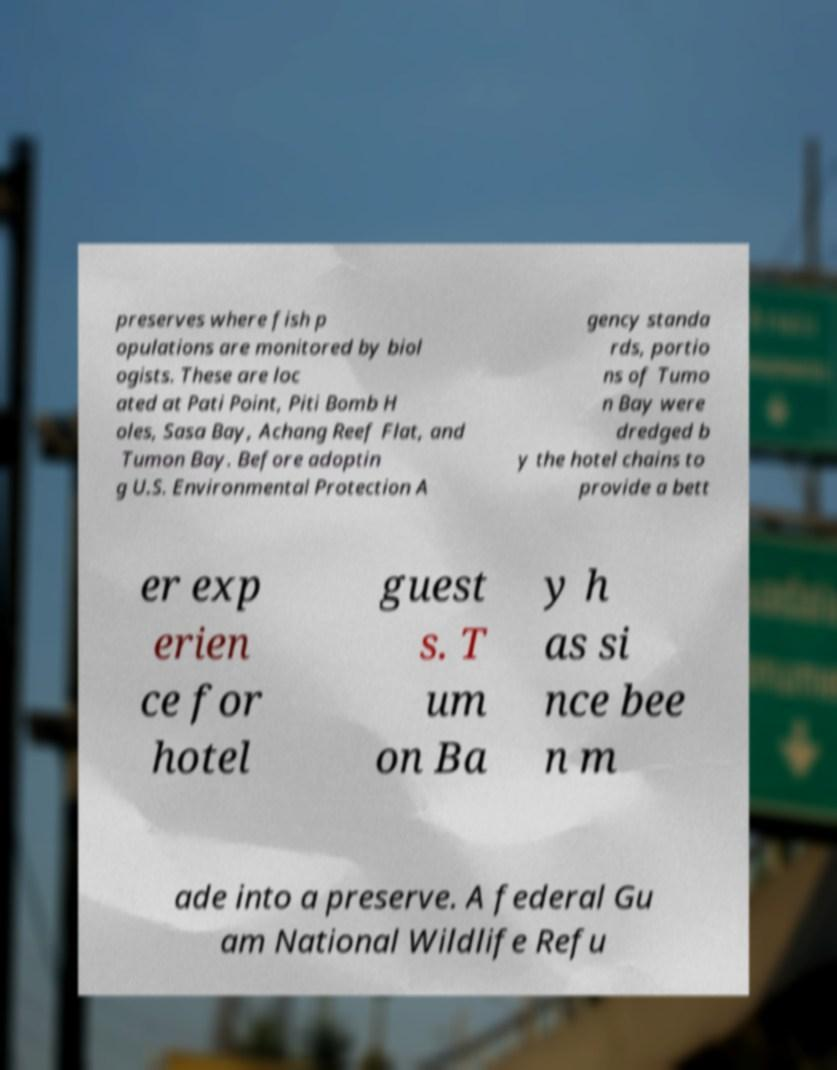Could you extract and type out the text from this image? preserves where fish p opulations are monitored by biol ogists. These are loc ated at Pati Point, Piti Bomb H oles, Sasa Bay, Achang Reef Flat, and Tumon Bay. Before adoptin g U.S. Environmental Protection A gency standa rds, portio ns of Tumo n Bay were dredged b y the hotel chains to provide a bett er exp erien ce for hotel guest s. T um on Ba y h as si nce bee n m ade into a preserve. A federal Gu am National Wildlife Refu 